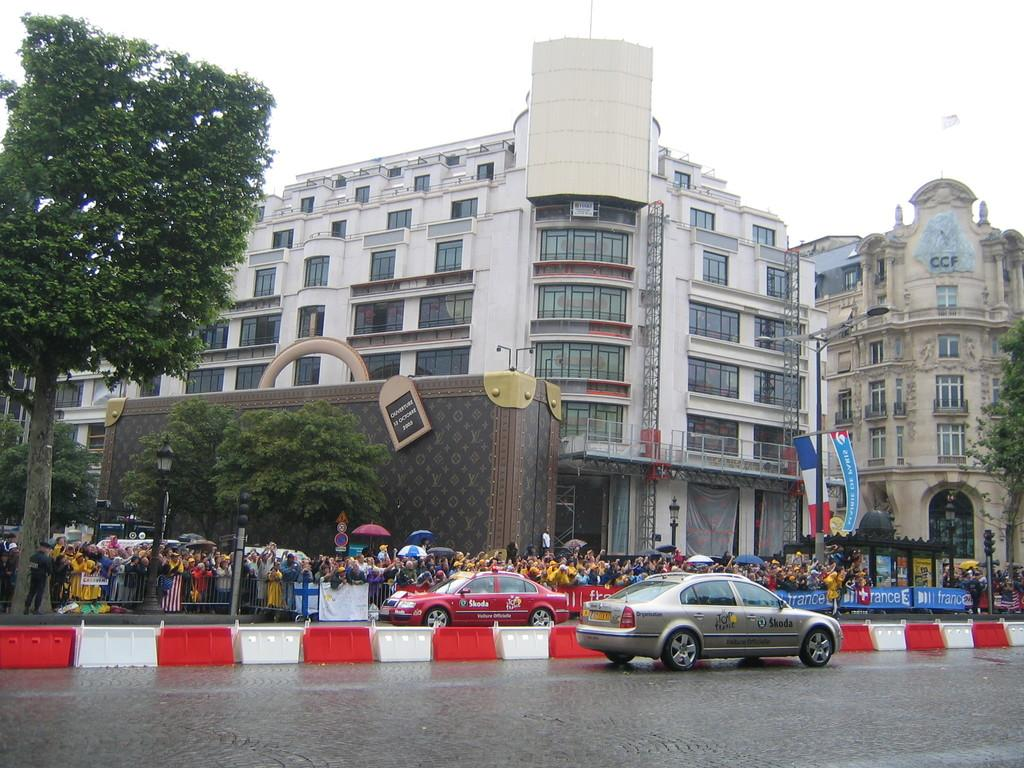<image>
Offer a succinct explanation of the picture presented. A red cab says Skoda on the door and is parked at an event. 